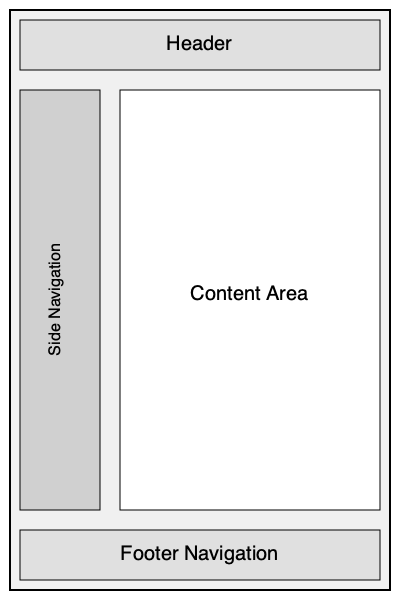Consider the mobile app interface layout shown above. Which navigation placement would be most effective for improving user experience and reducing frustration for users who frequently encounter usability issues? To determine the optimal placement of navigation elements in a mobile app interface, we need to consider several factors:

1. Thumb zone: The area of the screen that's easily reachable with the thumb while holding the device with one hand.

2. Screen real estate: The limited space available on mobile screens.

3. User expectations: Common patterns that users are familiar with from other apps.

4. Content visibility: Ensuring that navigation doesn't obstruct the main content.

5. Frequency of use: How often users need to access navigation elements.

Let's analyze each navigation option:

a) Header navigation:
   + Easily visible
   - Takes up valuable vertical space
   - Often outside the thumb zone for larger phones

b) Footer navigation:
   + Within the thumb zone
   + Doesn't obstruct content
   + Familiar pattern (used by many popular apps)
   - Requires scrolling to access if content is long

c) Side navigation:
   + Doesn't obstruct main content
   - Often hidden (requires an extra tap to access)
   - Can be difficult to reach with one hand
   - Less common in mobile apps (more suited for tablets or desktop)

Considering these factors, the footer navigation emerges as the most effective placement for mobile apps:

1. It's within the thumb zone, making it easy to reach and use with one hand.
2. It doesn't obstruct the main content area.
3. It's a familiar pattern that many users are accustomed to.
4. It remains accessible regardless of content length.
5. It allows for easy switching between different sections of the app.

This placement addresses the frustrations of users who encounter usability issues by providing a consistent, easily accessible navigation method that doesn't interfere with content consumption.
Answer: Footer navigation 